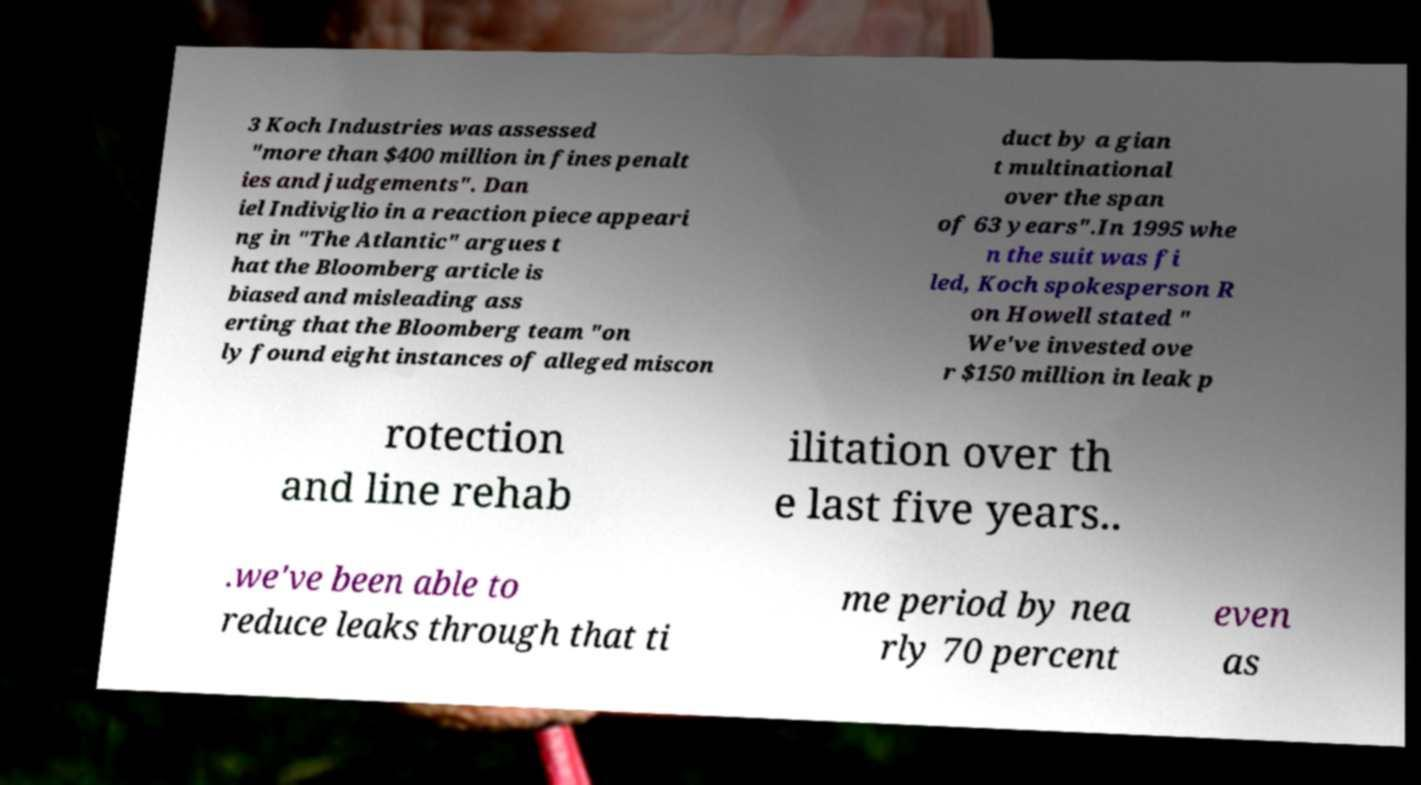Can you read and provide the text displayed in the image?This photo seems to have some interesting text. Can you extract and type it out for me? 3 Koch Industries was assessed "more than $400 million in fines penalt ies and judgements". Dan iel Indiviglio in a reaction piece appeari ng in "The Atlantic" argues t hat the Bloomberg article is biased and misleading ass erting that the Bloomberg team "on ly found eight instances of alleged miscon duct by a gian t multinational over the span of 63 years".In 1995 whe n the suit was fi led, Koch spokesperson R on Howell stated " We've invested ove r $150 million in leak p rotection and line rehab ilitation over th e last five years.. .we've been able to reduce leaks through that ti me period by nea rly 70 percent even as 